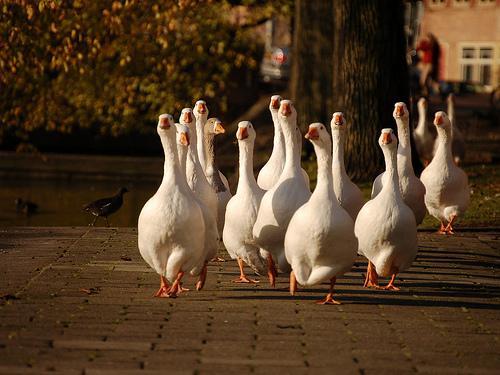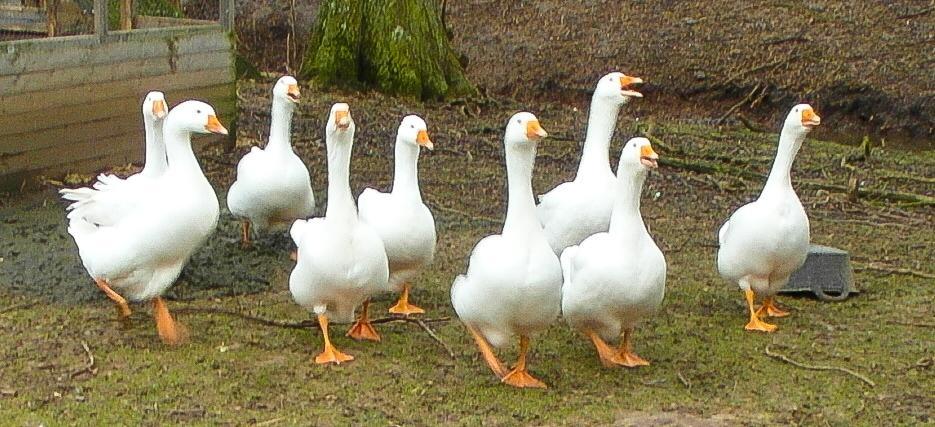The first image is the image on the left, the second image is the image on the right. Analyze the images presented: Is the assertion "At least one image shows no less than 20 white fowl." valid? Answer yes or no. No. The first image is the image on the left, the second image is the image on the right. Analyze the images presented: Is the assertion "One of the images shows exactly 6 geese." valid? Answer yes or no. No. 